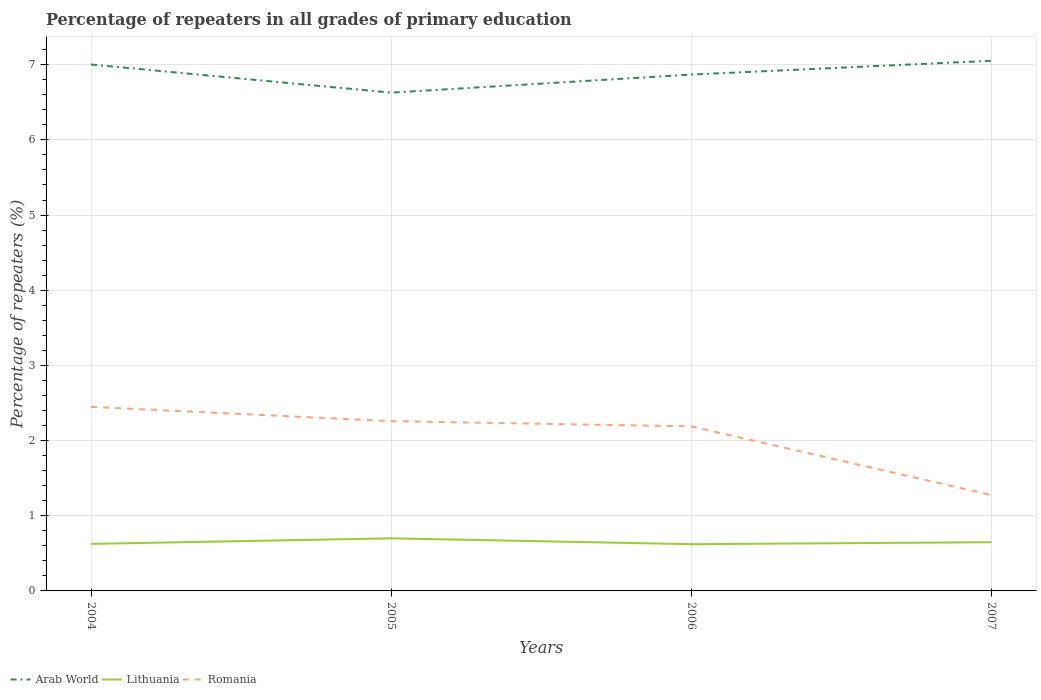Does the line corresponding to Romania intersect with the line corresponding to Lithuania?
Your answer should be very brief. No. Across all years, what is the maximum percentage of repeaters in Lithuania?
Ensure brevity in your answer.  0.62. What is the total percentage of repeaters in Arab World in the graph?
Give a very brief answer. -0.24. What is the difference between the highest and the second highest percentage of repeaters in Romania?
Provide a succinct answer. 1.17. How many lines are there?
Your answer should be very brief. 3. Are the values on the major ticks of Y-axis written in scientific E-notation?
Provide a succinct answer. No. Where does the legend appear in the graph?
Provide a short and direct response. Bottom left. What is the title of the graph?
Offer a terse response. Percentage of repeaters in all grades of primary education. What is the label or title of the Y-axis?
Give a very brief answer. Percentage of repeaters (%). What is the Percentage of repeaters (%) in Arab World in 2004?
Offer a very short reply. 7. What is the Percentage of repeaters (%) in Lithuania in 2004?
Provide a succinct answer. 0.63. What is the Percentage of repeaters (%) in Romania in 2004?
Your answer should be compact. 2.45. What is the Percentage of repeaters (%) in Arab World in 2005?
Your answer should be compact. 6.63. What is the Percentage of repeaters (%) in Lithuania in 2005?
Your response must be concise. 0.7. What is the Percentage of repeaters (%) of Romania in 2005?
Make the answer very short. 2.26. What is the Percentage of repeaters (%) of Arab World in 2006?
Your response must be concise. 6.87. What is the Percentage of repeaters (%) of Lithuania in 2006?
Offer a very short reply. 0.62. What is the Percentage of repeaters (%) in Romania in 2006?
Ensure brevity in your answer.  2.19. What is the Percentage of repeaters (%) of Arab World in 2007?
Your answer should be compact. 7.05. What is the Percentage of repeaters (%) of Lithuania in 2007?
Your response must be concise. 0.65. What is the Percentage of repeaters (%) of Romania in 2007?
Make the answer very short. 1.27. Across all years, what is the maximum Percentage of repeaters (%) in Arab World?
Your answer should be very brief. 7.05. Across all years, what is the maximum Percentage of repeaters (%) in Lithuania?
Offer a terse response. 0.7. Across all years, what is the maximum Percentage of repeaters (%) in Romania?
Give a very brief answer. 2.45. Across all years, what is the minimum Percentage of repeaters (%) of Arab World?
Keep it short and to the point. 6.63. Across all years, what is the minimum Percentage of repeaters (%) of Lithuania?
Ensure brevity in your answer.  0.62. Across all years, what is the minimum Percentage of repeaters (%) in Romania?
Your answer should be very brief. 1.27. What is the total Percentage of repeaters (%) in Arab World in the graph?
Offer a terse response. 27.55. What is the total Percentage of repeaters (%) in Lithuania in the graph?
Make the answer very short. 2.59. What is the total Percentage of repeaters (%) of Romania in the graph?
Offer a very short reply. 8.17. What is the difference between the Percentage of repeaters (%) of Arab World in 2004 and that in 2005?
Give a very brief answer. 0.37. What is the difference between the Percentage of repeaters (%) in Lithuania in 2004 and that in 2005?
Ensure brevity in your answer.  -0.07. What is the difference between the Percentage of repeaters (%) of Romania in 2004 and that in 2005?
Your answer should be compact. 0.19. What is the difference between the Percentage of repeaters (%) in Arab World in 2004 and that in 2006?
Give a very brief answer. 0.13. What is the difference between the Percentage of repeaters (%) of Lithuania in 2004 and that in 2006?
Provide a succinct answer. 0. What is the difference between the Percentage of repeaters (%) in Romania in 2004 and that in 2006?
Provide a short and direct response. 0.26. What is the difference between the Percentage of repeaters (%) of Arab World in 2004 and that in 2007?
Make the answer very short. -0.05. What is the difference between the Percentage of repeaters (%) in Lithuania in 2004 and that in 2007?
Keep it short and to the point. -0.02. What is the difference between the Percentage of repeaters (%) in Romania in 2004 and that in 2007?
Offer a terse response. 1.17. What is the difference between the Percentage of repeaters (%) in Arab World in 2005 and that in 2006?
Your answer should be very brief. -0.24. What is the difference between the Percentage of repeaters (%) in Lithuania in 2005 and that in 2006?
Give a very brief answer. 0.08. What is the difference between the Percentage of repeaters (%) of Romania in 2005 and that in 2006?
Offer a terse response. 0.07. What is the difference between the Percentage of repeaters (%) of Arab World in 2005 and that in 2007?
Your answer should be compact. -0.42. What is the difference between the Percentage of repeaters (%) of Lithuania in 2005 and that in 2007?
Keep it short and to the point. 0.05. What is the difference between the Percentage of repeaters (%) of Romania in 2005 and that in 2007?
Give a very brief answer. 0.98. What is the difference between the Percentage of repeaters (%) of Arab World in 2006 and that in 2007?
Provide a short and direct response. -0.18. What is the difference between the Percentage of repeaters (%) of Lithuania in 2006 and that in 2007?
Make the answer very short. -0.03. What is the difference between the Percentage of repeaters (%) of Romania in 2006 and that in 2007?
Offer a very short reply. 0.91. What is the difference between the Percentage of repeaters (%) of Arab World in 2004 and the Percentage of repeaters (%) of Lithuania in 2005?
Make the answer very short. 6.3. What is the difference between the Percentage of repeaters (%) of Arab World in 2004 and the Percentage of repeaters (%) of Romania in 2005?
Offer a very short reply. 4.74. What is the difference between the Percentage of repeaters (%) of Lithuania in 2004 and the Percentage of repeaters (%) of Romania in 2005?
Ensure brevity in your answer.  -1.63. What is the difference between the Percentage of repeaters (%) in Arab World in 2004 and the Percentage of repeaters (%) in Lithuania in 2006?
Offer a terse response. 6.38. What is the difference between the Percentage of repeaters (%) in Arab World in 2004 and the Percentage of repeaters (%) in Romania in 2006?
Give a very brief answer. 4.81. What is the difference between the Percentage of repeaters (%) in Lithuania in 2004 and the Percentage of repeaters (%) in Romania in 2006?
Keep it short and to the point. -1.56. What is the difference between the Percentage of repeaters (%) in Arab World in 2004 and the Percentage of repeaters (%) in Lithuania in 2007?
Ensure brevity in your answer.  6.35. What is the difference between the Percentage of repeaters (%) in Arab World in 2004 and the Percentage of repeaters (%) in Romania in 2007?
Keep it short and to the point. 5.73. What is the difference between the Percentage of repeaters (%) of Lithuania in 2004 and the Percentage of repeaters (%) of Romania in 2007?
Provide a succinct answer. -0.65. What is the difference between the Percentage of repeaters (%) in Arab World in 2005 and the Percentage of repeaters (%) in Lithuania in 2006?
Make the answer very short. 6.01. What is the difference between the Percentage of repeaters (%) in Arab World in 2005 and the Percentage of repeaters (%) in Romania in 2006?
Provide a succinct answer. 4.44. What is the difference between the Percentage of repeaters (%) in Lithuania in 2005 and the Percentage of repeaters (%) in Romania in 2006?
Offer a terse response. -1.49. What is the difference between the Percentage of repeaters (%) of Arab World in 2005 and the Percentage of repeaters (%) of Lithuania in 2007?
Provide a short and direct response. 5.98. What is the difference between the Percentage of repeaters (%) of Arab World in 2005 and the Percentage of repeaters (%) of Romania in 2007?
Provide a short and direct response. 5.35. What is the difference between the Percentage of repeaters (%) in Lithuania in 2005 and the Percentage of repeaters (%) in Romania in 2007?
Offer a very short reply. -0.57. What is the difference between the Percentage of repeaters (%) in Arab World in 2006 and the Percentage of repeaters (%) in Lithuania in 2007?
Provide a succinct answer. 6.22. What is the difference between the Percentage of repeaters (%) in Arab World in 2006 and the Percentage of repeaters (%) in Romania in 2007?
Make the answer very short. 5.59. What is the difference between the Percentage of repeaters (%) of Lithuania in 2006 and the Percentage of repeaters (%) of Romania in 2007?
Give a very brief answer. -0.65. What is the average Percentage of repeaters (%) in Arab World per year?
Your answer should be very brief. 6.89. What is the average Percentage of repeaters (%) of Lithuania per year?
Provide a succinct answer. 0.65. What is the average Percentage of repeaters (%) in Romania per year?
Provide a short and direct response. 2.04. In the year 2004, what is the difference between the Percentage of repeaters (%) of Arab World and Percentage of repeaters (%) of Lithuania?
Offer a terse response. 6.38. In the year 2004, what is the difference between the Percentage of repeaters (%) in Arab World and Percentage of repeaters (%) in Romania?
Provide a short and direct response. 4.55. In the year 2004, what is the difference between the Percentage of repeaters (%) in Lithuania and Percentage of repeaters (%) in Romania?
Offer a very short reply. -1.82. In the year 2005, what is the difference between the Percentage of repeaters (%) of Arab World and Percentage of repeaters (%) of Lithuania?
Your answer should be very brief. 5.93. In the year 2005, what is the difference between the Percentage of repeaters (%) in Arab World and Percentage of repeaters (%) in Romania?
Give a very brief answer. 4.37. In the year 2005, what is the difference between the Percentage of repeaters (%) in Lithuania and Percentage of repeaters (%) in Romania?
Ensure brevity in your answer.  -1.56. In the year 2006, what is the difference between the Percentage of repeaters (%) in Arab World and Percentage of repeaters (%) in Lithuania?
Offer a terse response. 6.25. In the year 2006, what is the difference between the Percentage of repeaters (%) in Arab World and Percentage of repeaters (%) in Romania?
Offer a very short reply. 4.68. In the year 2006, what is the difference between the Percentage of repeaters (%) in Lithuania and Percentage of repeaters (%) in Romania?
Keep it short and to the point. -1.57. In the year 2007, what is the difference between the Percentage of repeaters (%) in Arab World and Percentage of repeaters (%) in Lithuania?
Your response must be concise. 6.4. In the year 2007, what is the difference between the Percentage of repeaters (%) of Arab World and Percentage of repeaters (%) of Romania?
Offer a very short reply. 5.78. In the year 2007, what is the difference between the Percentage of repeaters (%) of Lithuania and Percentage of repeaters (%) of Romania?
Give a very brief answer. -0.63. What is the ratio of the Percentage of repeaters (%) in Arab World in 2004 to that in 2005?
Offer a terse response. 1.06. What is the ratio of the Percentage of repeaters (%) in Lithuania in 2004 to that in 2005?
Provide a succinct answer. 0.89. What is the ratio of the Percentage of repeaters (%) in Romania in 2004 to that in 2005?
Offer a terse response. 1.08. What is the ratio of the Percentage of repeaters (%) in Arab World in 2004 to that in 2006?
Make the answer very short. 1.02. What is the ratio of the Percentage of repeaters (%) in Lithuania in 2004 to that in 2006?
Provide a succinct answer. 1.01. What is the ratio of the Percentage of repeaters (%) in Romania in 2004 to that in 2006?
Your answer should be very brief. 1.12. What is the ratio of the Percentage of repeaters (%) in Arab World in 2004 to that in 2007?
Ensure brevity in your answer.  0.99. What is the ratio of the Percentage of repeaters (%) in Lithuania in 2004 to that in 2007?
Keep it short and to the point. 0.97. What is the ratio of the Percentage of repeaters (%) of Romania in 2004 to that in 2007?
Offer a very short reply. 1.92. What is the ratio of the Percentage of repeaters (%) of Arab World in 2005 to that in 2006?
Offer a very short reply. 0.96. What is the ratio of the Percentage of repeaters (%) of Lithuania in 2005 to that in 2006?
Your answer should be compact. 1.13. What is the ratio of the Percentage of repeaters (%) in Romania in 2005 to that in 2006?
Offer a terse response. 1.03. What is the ratio of the Percentage of repeaters (%) in Arab World in 2005 to that in 2007?
Your response must be concise. 0.94. What is the ratio of the Percentage of repeaters (%) of Lithuania in 2005 to that in 2007?
Your answer should be very brief. 1.08. What is the ratio of the Percentage of repeaters (%) in Romania in 2005 to that in 2007?
Ensure brevity in your answer.  1.77. What is the ratio of the Percentage of repeaters (%) in Arab World in 2006 to that in 2007?
Keep it short and to the point. 0.97. What is the ratio of the Percentage of repeaters (%) of Lithuania in 2006 to that in 2007?
Offer a terse response. 0.96. What is the ratio of the Percentage of repeaters (%) in Romania in 2006 to that in 2007?
Make the answer very short. 1.72. What is the difference between the highest and the second highest Percentage of repeaters (%) of Arab World?
Provide a succinct answer. 0.05. What is the difference between the highest and the second highest Percentage of repeaters (%) of Lithuania?
Keep it short and to the point. 0.05. What is the difference between the highest and the second highest Percentage of repeaters (%) of Romania?
Offer a terse response. 0.19. What is the difference between the highest and the lowest Percentage of repeaters (%) of Arab World?
Provide a short and direct response. 0.42. What is the difference between the highest and the lowest Percentage of repeaters (%) in Lithuania?
Offer a terse response. 0.08. What is the difference between the highest and the lowest Percentage of repeaters (%) in Romania?
Your answer should be compact. 1.17. 